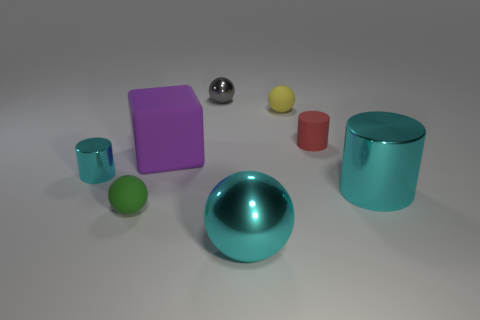Is the color of the big cylinder the same as the tiny cylinder on the left side of the big cube?
Your response must be concise. Yes. How many other objects are the same size as the green matte ball?
Give a very brief answer. 4. What is the size of the ball that is the same color as the big metallic cylinder?
Ensure brevity in your answer.  Large. Is the number of gray things behind the tiny cyan cylinder greater than the number of tiny rubber cubes?
Provide a short and direct response. Yes. Are there any big shiny things that have the same color as the big shiny ball?
Your response must be concise. Yes. There is a metallic cylinder that is the same size as the rubber cylinder; what is its color?
Your answer should be compact. Cyan. What number of large things are in front of the large thing that is on the left side of the big ball?
Your answer should be compact. 2. What number of things are cyan shiny things in front of the green sphere or small metallic objects?
Keep it short and to the point. 3. What number of tiny things are made of the same material as the small cyan cylinder?
Provide a succinct answer. 1. What shape is the tiny metal thing that is the same color as the large sphere?
Your answer should be very brief. Cylinder. 